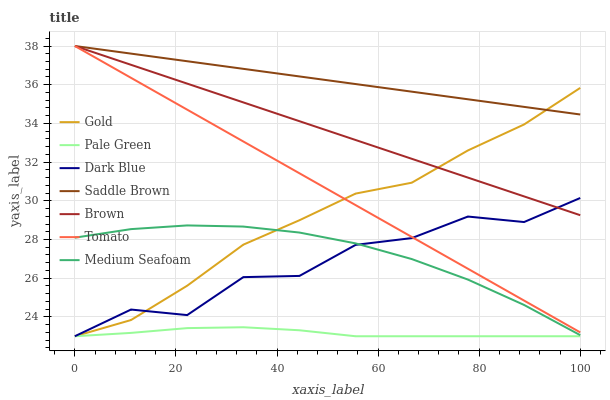Does Pale Green have the minimum area under the curve?
Answer yes or no. Yes. Does Saddle Brown have the maximum area under the curve?
Answer yes or no. Yes. Does Brown have the minimum area under the curve?
Answer yes or no. No. Does Brown have the maximum area under the curve?
Answer yes or no. No. Is Brown the smoothest?
Answer yes or no. Yes. Is Dark Blue the roughest?
Answer yes or no. Yes. Is Gold the smoothest?
Answer yes or no. No. Is Gold the roughest?
Answer yes or no. No. Does Gold have the lowest value?
Answer yes or no. Yes. Does Brown have the lowest value?
Answer yes or no. No. Does Saddle Brown have the highest value?
Answer yes or no. Yes. Does Gold have the highest value?
Answer yes or no. No. Is Pale Green less than Medium Seafoam?
Answer yes or no. Yes. Is Dark Blue greater than Pale Green?
Answer yes or no. Yes. Does Brown intersect Tomato?
Answer yes or no. Yes. Is Brown less than Tomato?
Answer yes or no. No. Is Brown greater than Tomato?
Answer yes or no. No. Does Pale Green intersect Medium Seafoam?
Answer yes or no. No. 